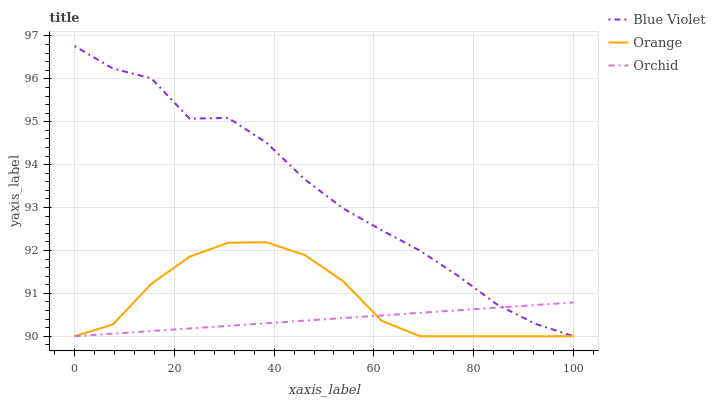Does Orchid have the minimum area under the curve?
Answer yes or no. Yes. Does Blue Violet have the maximum area under the curve?
Answer yes or no. Yes. Does Blue Violet have the minimum area under the curve?
Answer yes or no. No. Does Orchid have the maximum area under the curve?
Answer yes or no. No. Is Orchid the smoothest?
Answer yes or no. Yes. Is Blue Violet the roughest?
Answer yes or no. Yes. Is Blue Violet the smoothest?
Answer yes or no. No. Is Orchid the roughest?
Answer yes or no. No. Does Orange have the lowest value?
Answer yes or no. Yes. Does Blue Violet have the highest value?
Answer yes or no. Yes. Does Orchid have the highest value?
Answer yes or no. No. Does Orchid intersect Orange?
Answer yes or no. Yes. Is Orchid less than Orange?
Answer yes or no. No. Is Orchid greater than Orange?
Answer yes or no. No. 